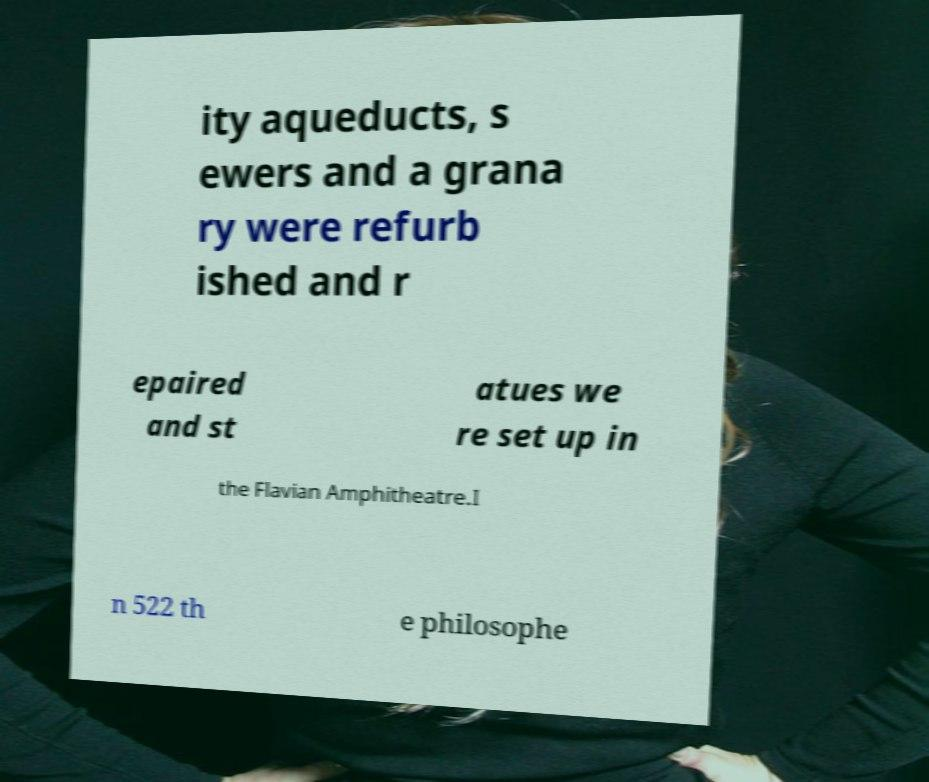Can you read and provide the text displayed in the image?This photo seems to have some interesting text. Can you extract and type it out for me? ity aqueducts, s ewers and a grana ry were refurb ished and r epaired and st atues we re set up in the Flavian Amphitheatre.I n 522 th e philosophe 